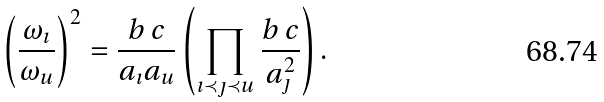<formula> <loc_0><loc_0><loc_500><loc_500>\left ( \frac { \omega _ { \imath } } { \omega _ { u } } \right ) ^ { 2 } = \frac { b \, c } { a _ { \imath } a _ { u } } \left ( \prod _ { \imath \prec \jmath \prec u } \frac { b \, c } { a ^ { 2 } _ { \jmath } } \right ) .</formula> 